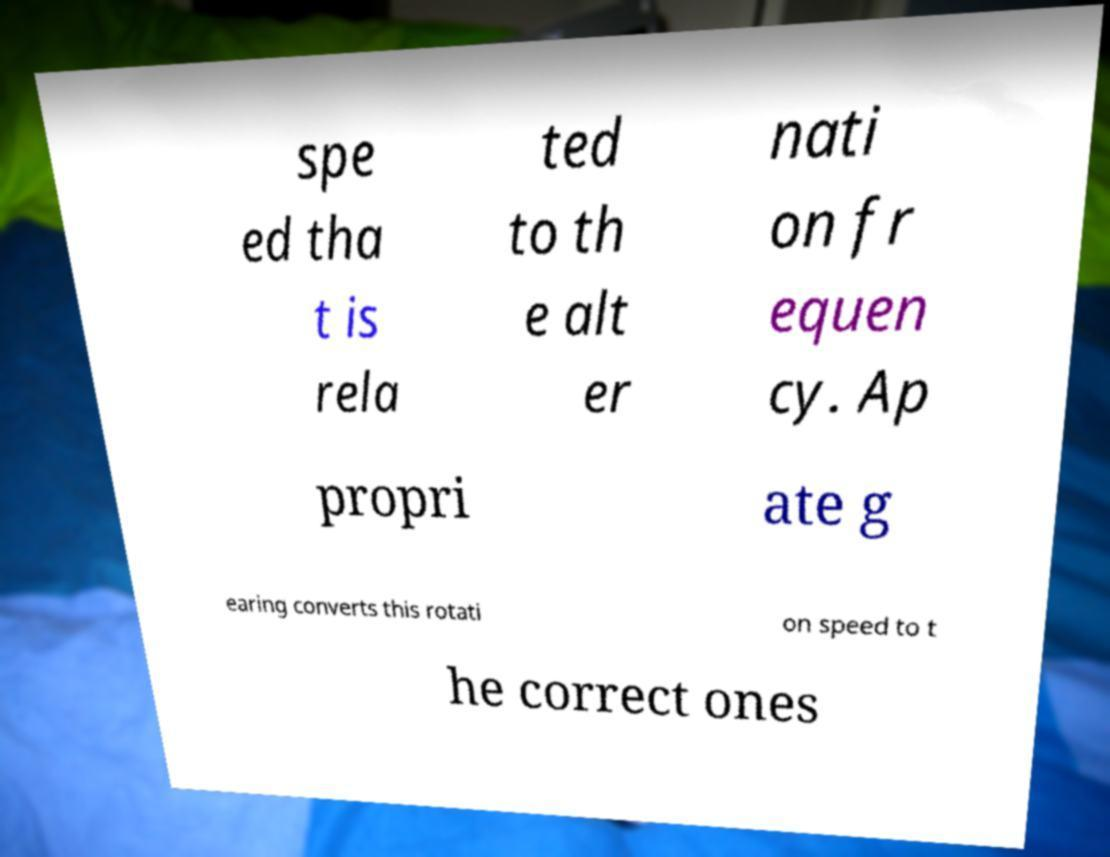There's text embedded in this image that I need extracted. Can you transcribe it verbatim? spe ed tha t is rela ted to th e alt er nati on fr equen cy. Ap propri ate g earing converts this rotati on speed to t he correct ones 